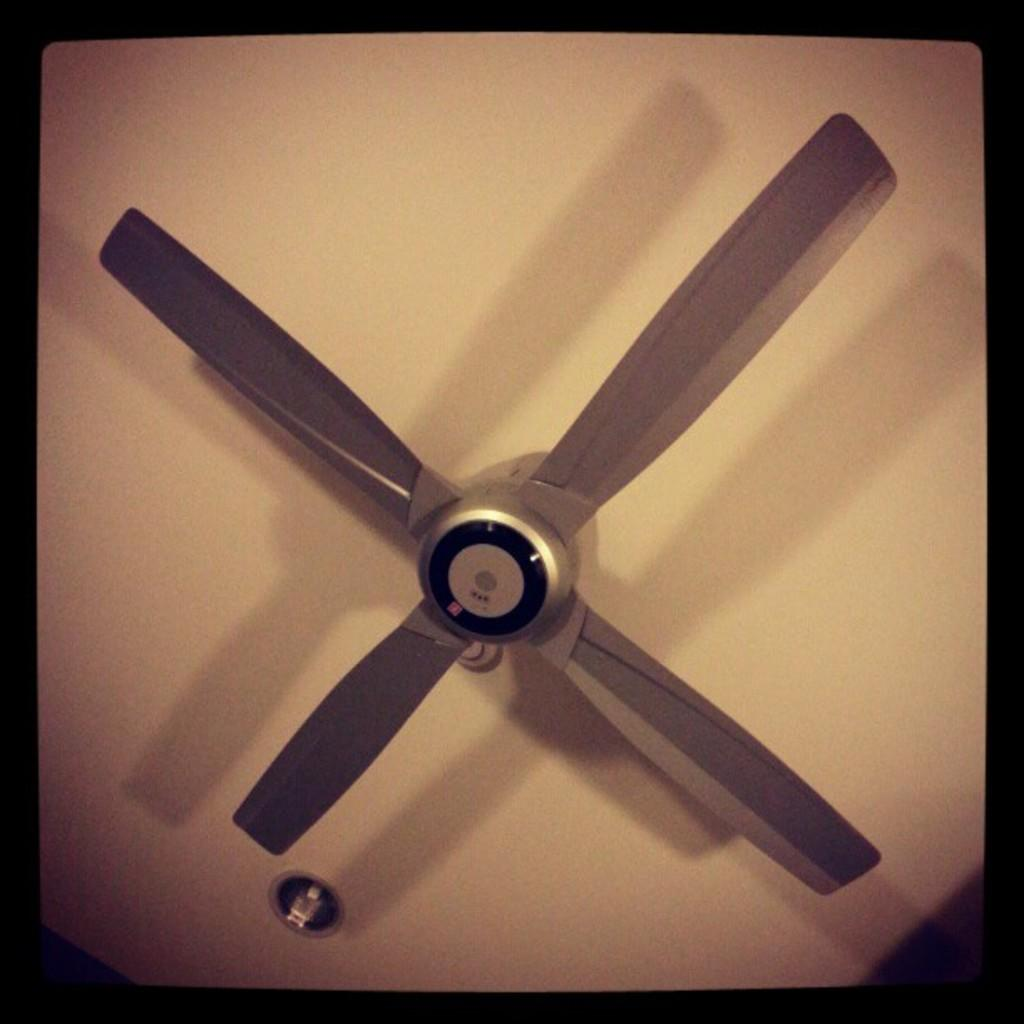What type of device is hanging from the roof in the image? There is a ceiling fan in the image. How is the ceiling fan connected to the roof? The ceiling fan is attached to the roof. What type of cord is hanging from the ceiling fan in the image? There is no cord hanging from the ceiling fan in the image. How does the wind affect the movement of the ceiling fan in the image? The image does not show any wind, and the ceiling fan's movement is not affected by wind in the image. 